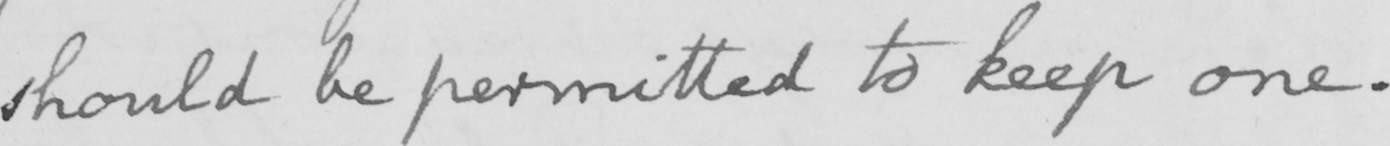Please transcribe the handwritten text in this image. should be permitted to keep one . 